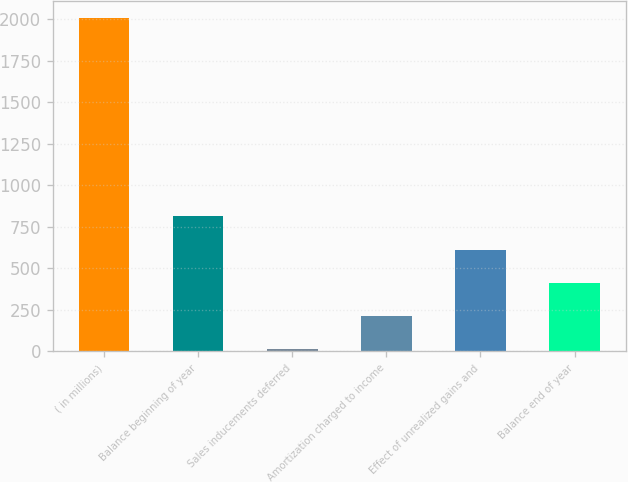Convert chart to OTSL. <chart><loc_0><loc_0><loc_500><loc_500><bar_chart><fcel>( in millions)<fcel>Balance beginning of year<fcel>Sales inducements deferred<fcel>Amortization charged to income<fcel>Effect of unrealized gains and<fcel>Balance end of year<nl><fcel>2010<fcel>812.4<fcel>14<fcel>213.6<fcel>612.8<fcel>413.2<nl></chart> 